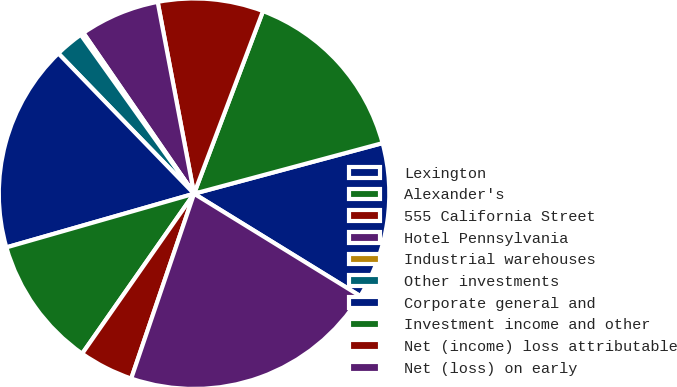<chart> <loc_0><loc_0><loc_500><loc_500><pie_chart><fcel>Lexington<fcel>Alexander's<fcel>555 California Street<fcel>Hotel Pennsylvania<fcel>Industrial warehouses<fcel>Other investments<fcel>Corporate general and<fcel>Investment income and other<fcel>Net (income) loss attributable<fcel>Net (loss) on early<nl><fcel>12.96%<fcel>15.08%<fcel>8.73%<fcel>6.61%<fcel>0.26%<fcel>2.38%<fcel>17.2%<fcel>10.85%<fcel>4.5%<fcel>21.43%<nl></chart> 